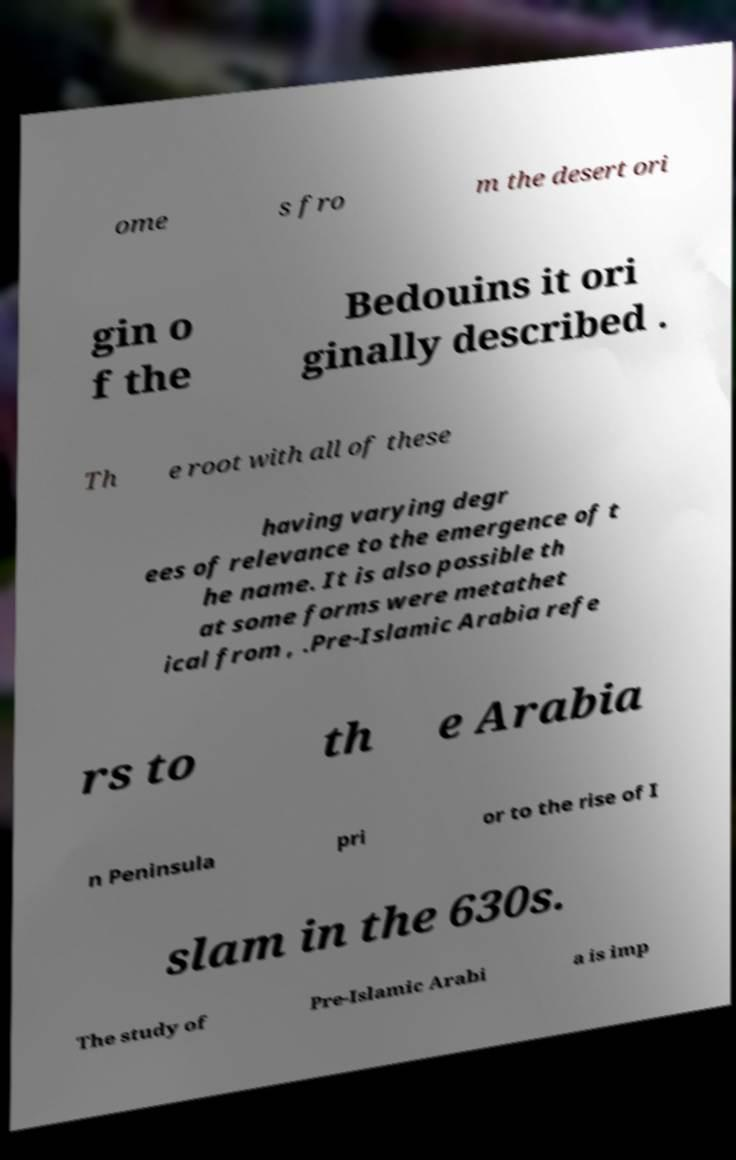There's text embedded in this image that I need extracted. Can you transcribe it verbatim? ome s fro m the desert ori gin o f the Bedouins it ori ginally described . Th e root with all of these having varying degr ees of relevance to the emergence of t he name. It is also possible th at some forms were metathet ical from , .Pre-Islamic Arabia refe rs to th e Arabia n Peninsula pri or to the rise of I slam in the 630s. The study of Pre-Islamic Arabi a is imp 